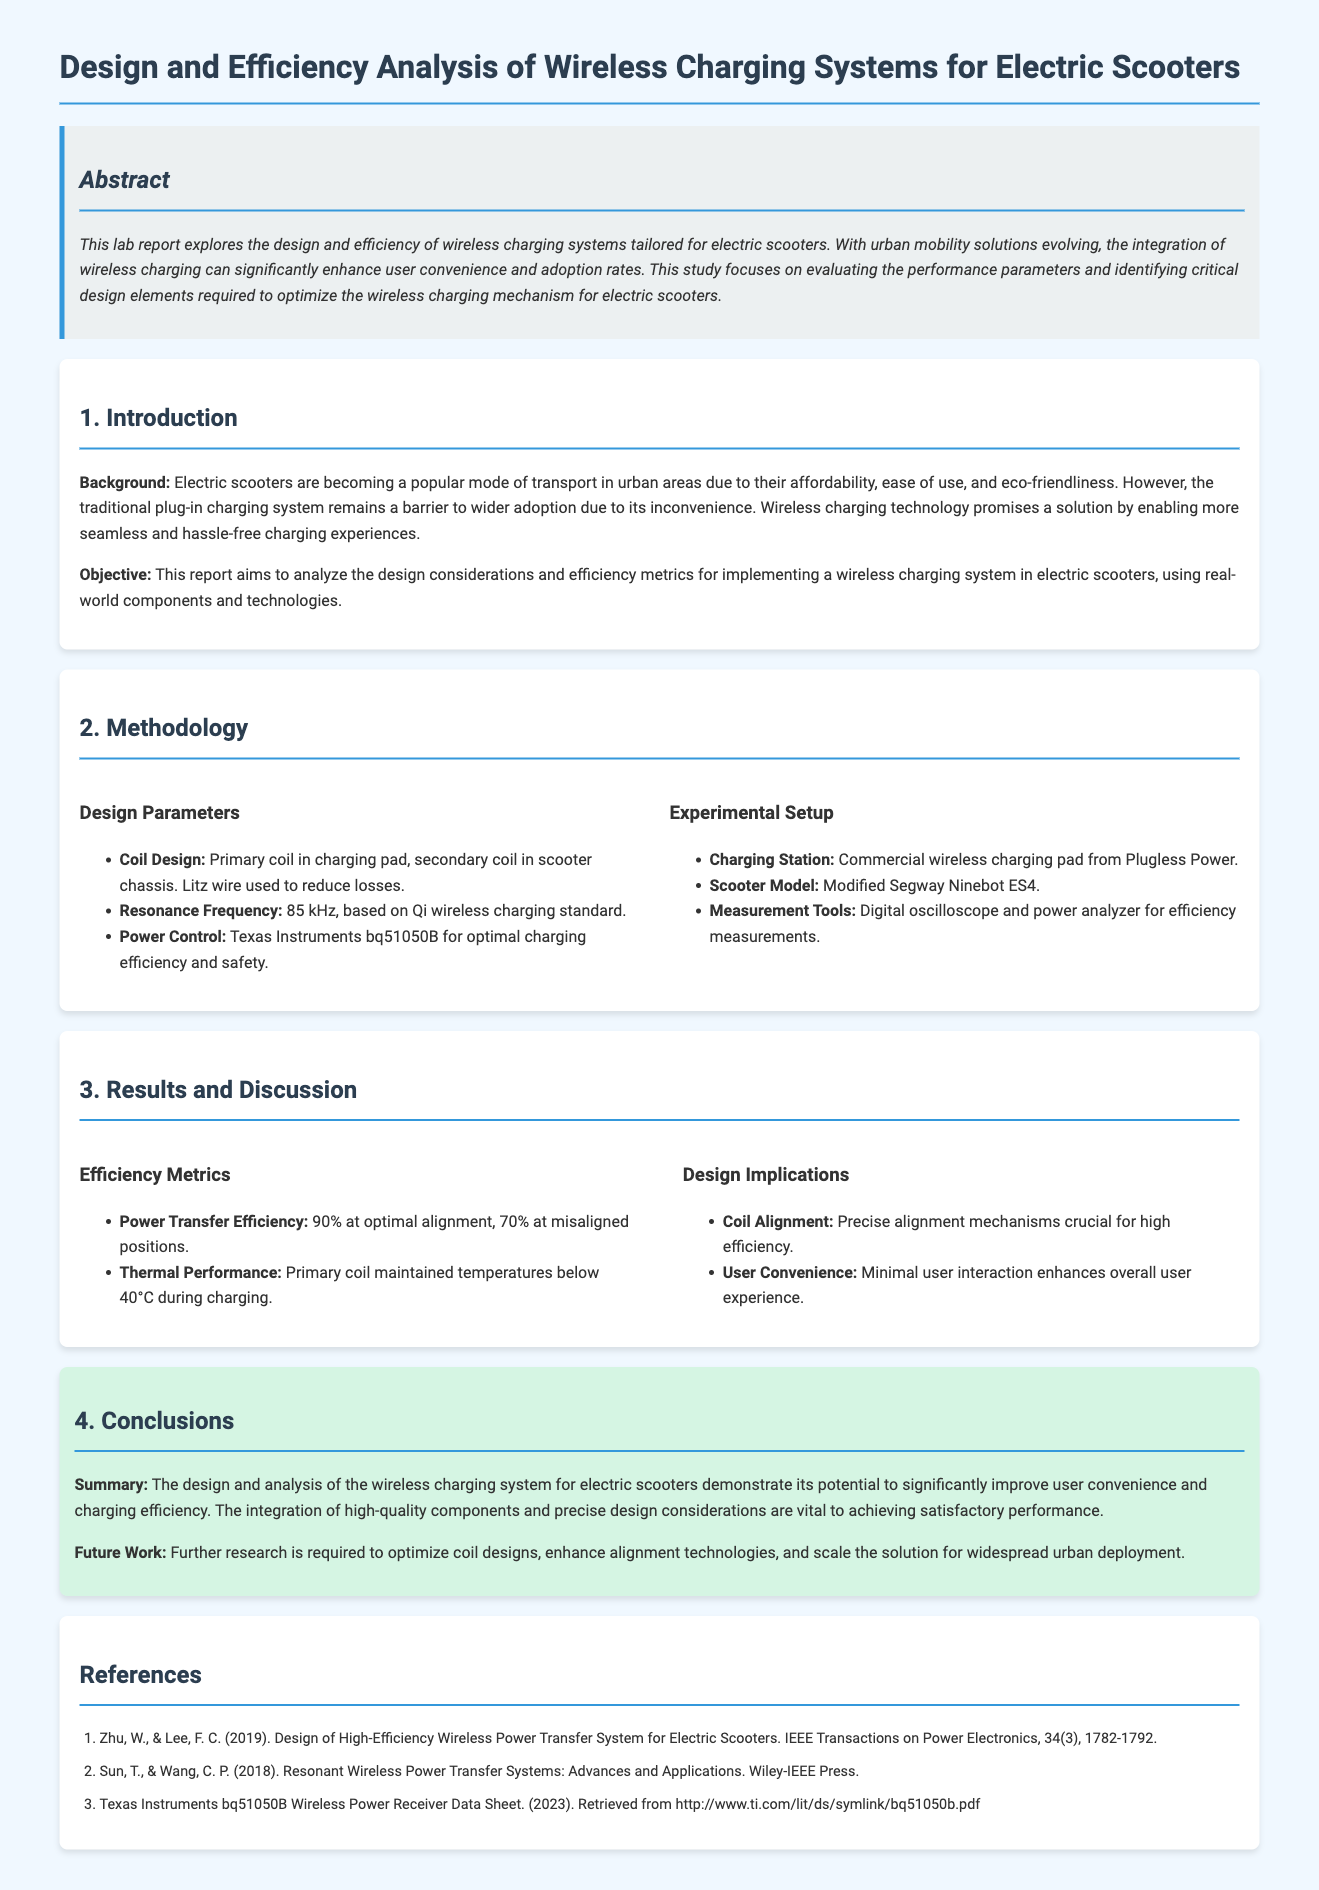What is the primary coil material used in the charging pad? The report states that Litz wire is used to reduce losses in the primary coil design.
Answer: Litz wire What is the resonance frequency for the wireless charging system? According to the methodology section, the resonance frequency is specified to be 85 kHz.
Answer: 85 kHz What is the power transfer efficiency at optimal alignment? The efficiency metrics indicate that the power transfer efficiency is 90% at optimal alignment.
Answer: 90% What are the maximum temperatures maintained by the primary coil during charging? The results indicate that the primary coil maintained temperatures below 40°C during the charging process.
Answer: 40°C Why is precise coil alignment crucial? The design implications section states that precise alignment mechanisms are crucial for high efficiency.
Answer: High efficiency What component is used for power control in the system? The methodology mentions the use of Texas Instruments bq51050B for optimal charging efficiency.
Answer: Texas Instruments bq51050B What scooter model was used for the experimental setup? The report specifies that a modified Segway Ninebot ES4 scooter model was utilized in the experiments.
Answer: Segway Ninebot ES4 What is the objective of the lab report? The objective outlined in the introduction is to analyze the design considerations and efficiency metrics for wireless charging systems in electric scooters.
Answer: Analyze design considerations and efficiency metrics What is identified as a future research direction in the report? The conclusions section suggests that further research is needed to optimize coil designs and enhance alignment technologies.
Answer: Optimize coil designs 